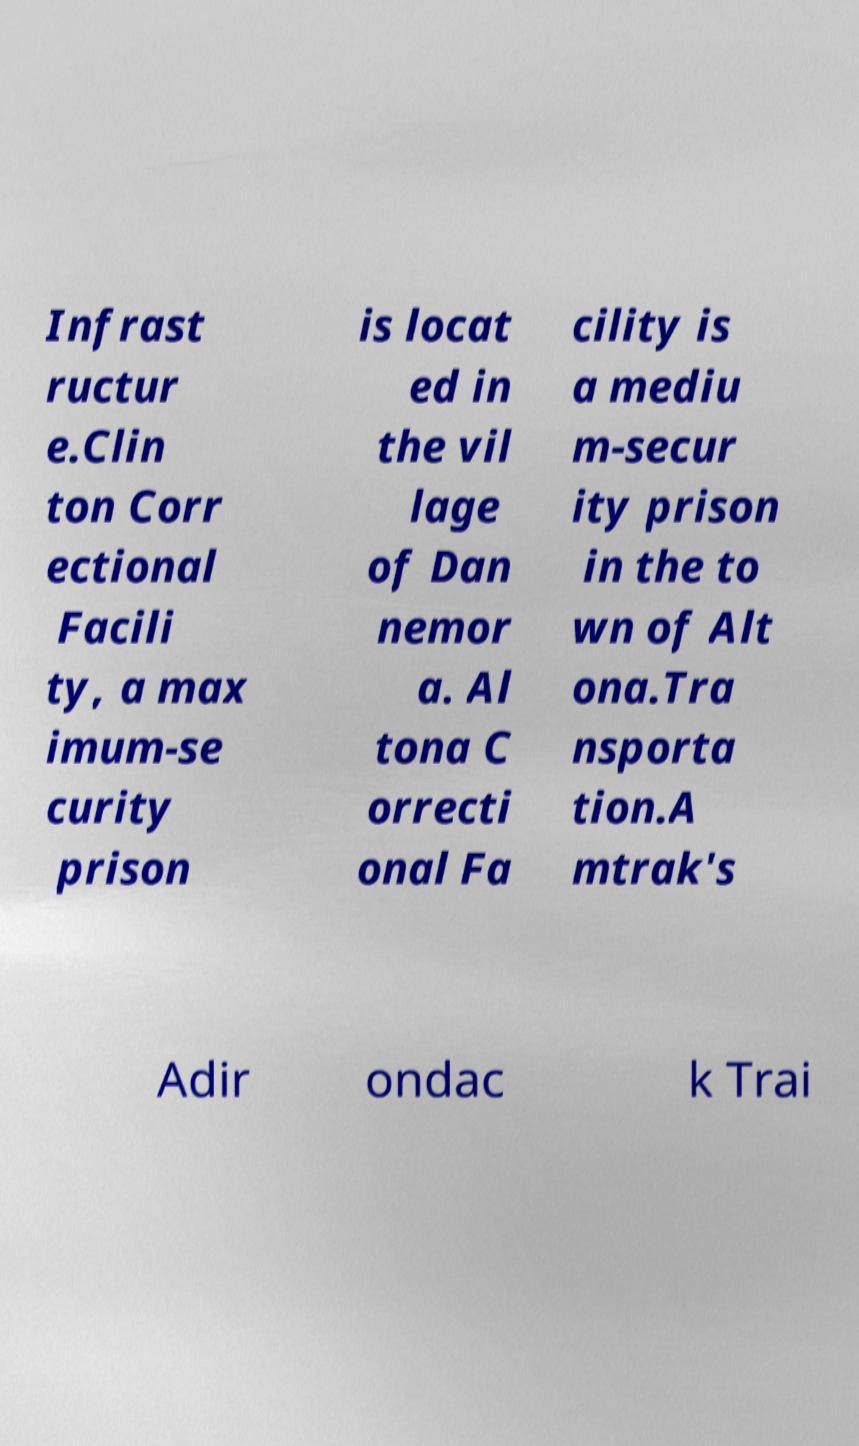What messages or text are displayed in this image? I need them in a readable, typed format. Infrast ructur e.Clin ton Corr ectional Facili ty, a max imum-se curity prison is locat ed in the vil lage of Dan nemor a. Al tona C orrecti onal Fa cility is a mediu m-secur ity prison in the to wn of Alt ona.Tra nsporta tion.A mtrak's Adir ondac k Trai 